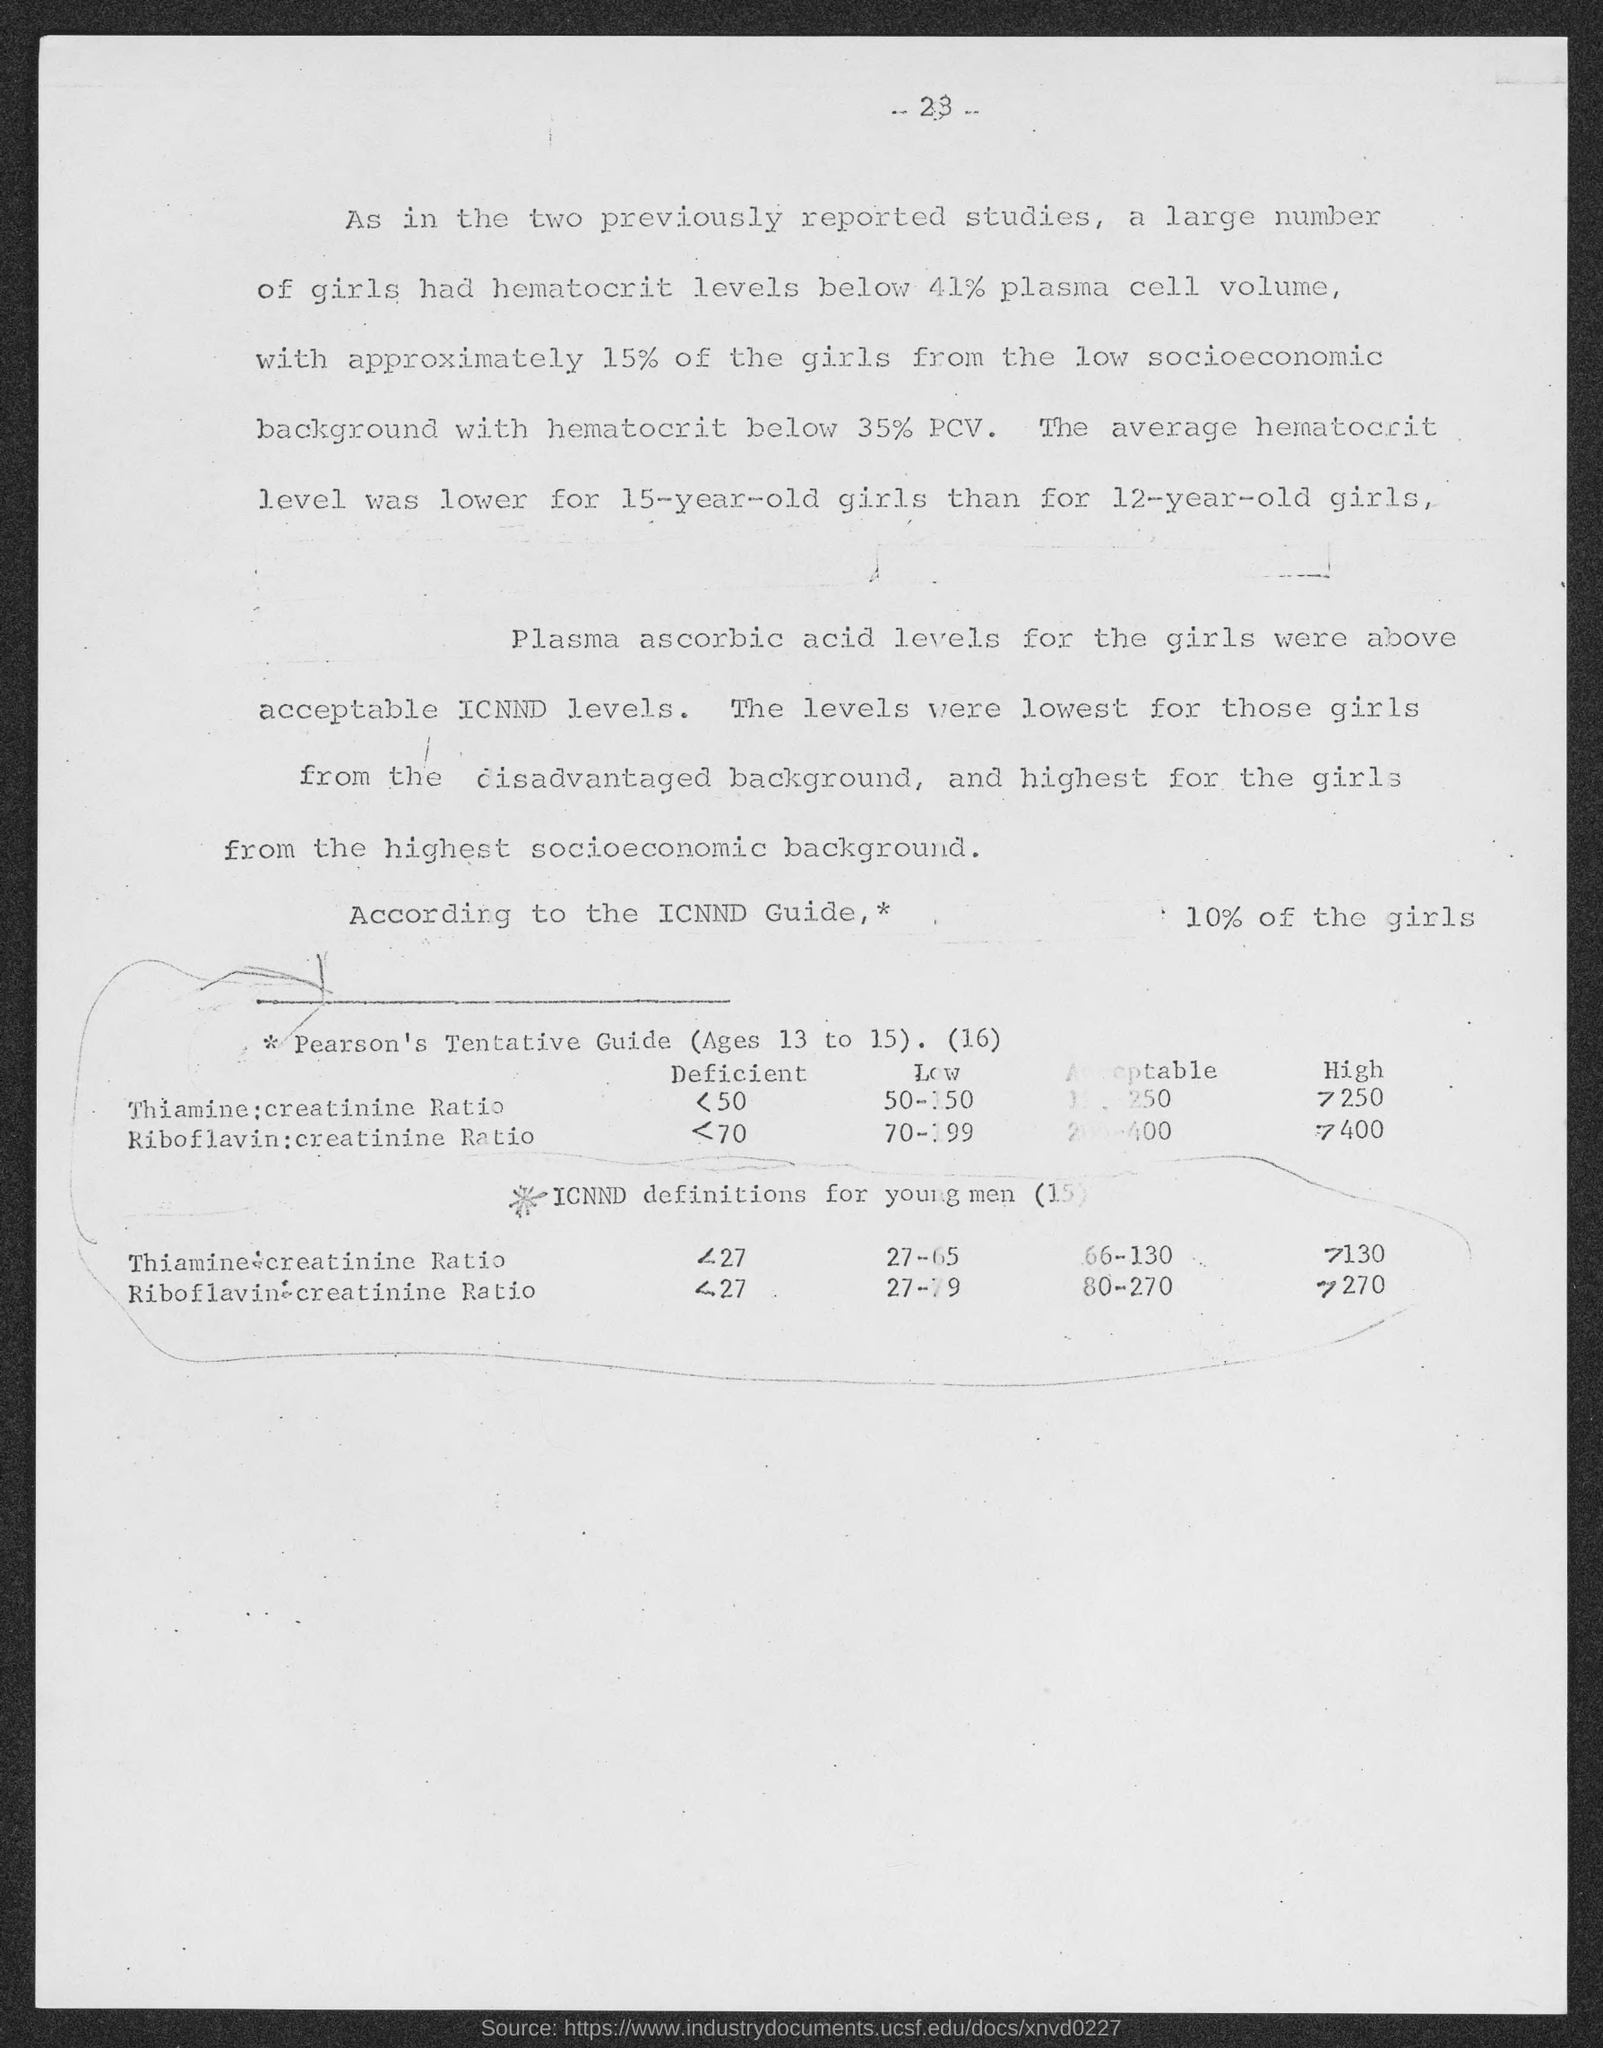What is the page number at top of the page ?
Keep it short and to the point. 23. 